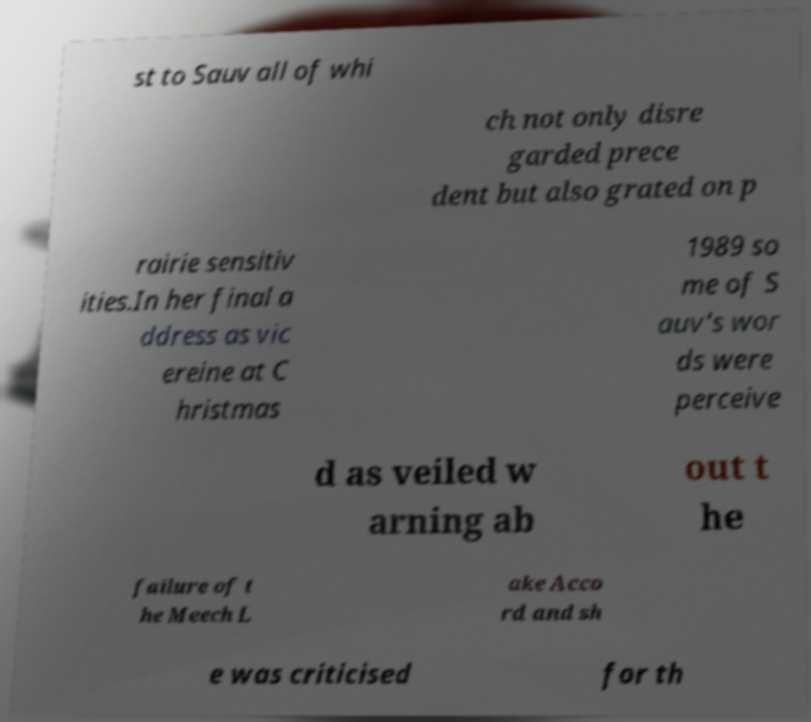Please identify and transcribe the text found in this image. st to Sauv all of whi ch not only disre garded prece dent but also grated on p rairie sensitiv ities.In her final a ddress as vic ereine at C hristmas 1989 so me of S auv's wor ds were perceive d as veiled w arning ab out t he failure of t he Meech L ake Acco rd and sh e was criticised for th 